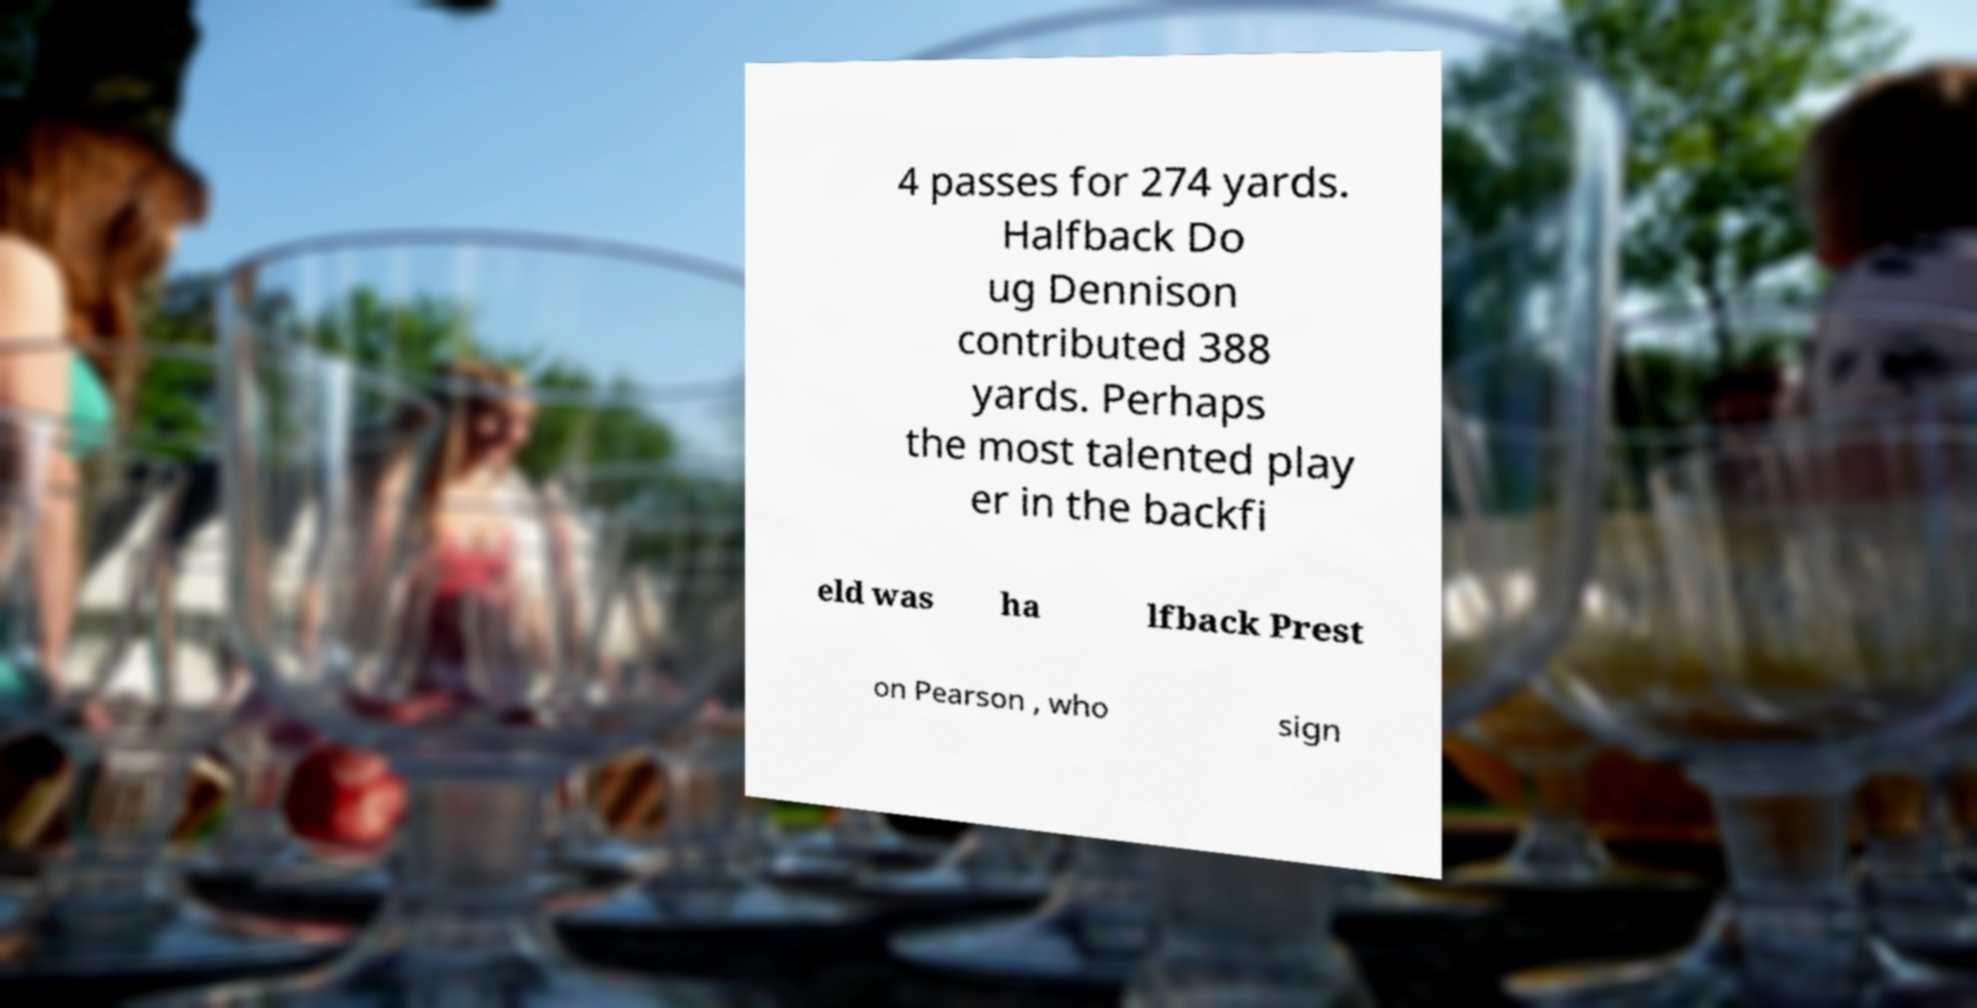Please identify and transcribe the text found in this image. 4 passes for 274 yards. Halfback Do ug Dennison contributed 388 yards. Perhaps the most talented play er in the backfi eld was ha lfback Prest on Pearson , who sign 